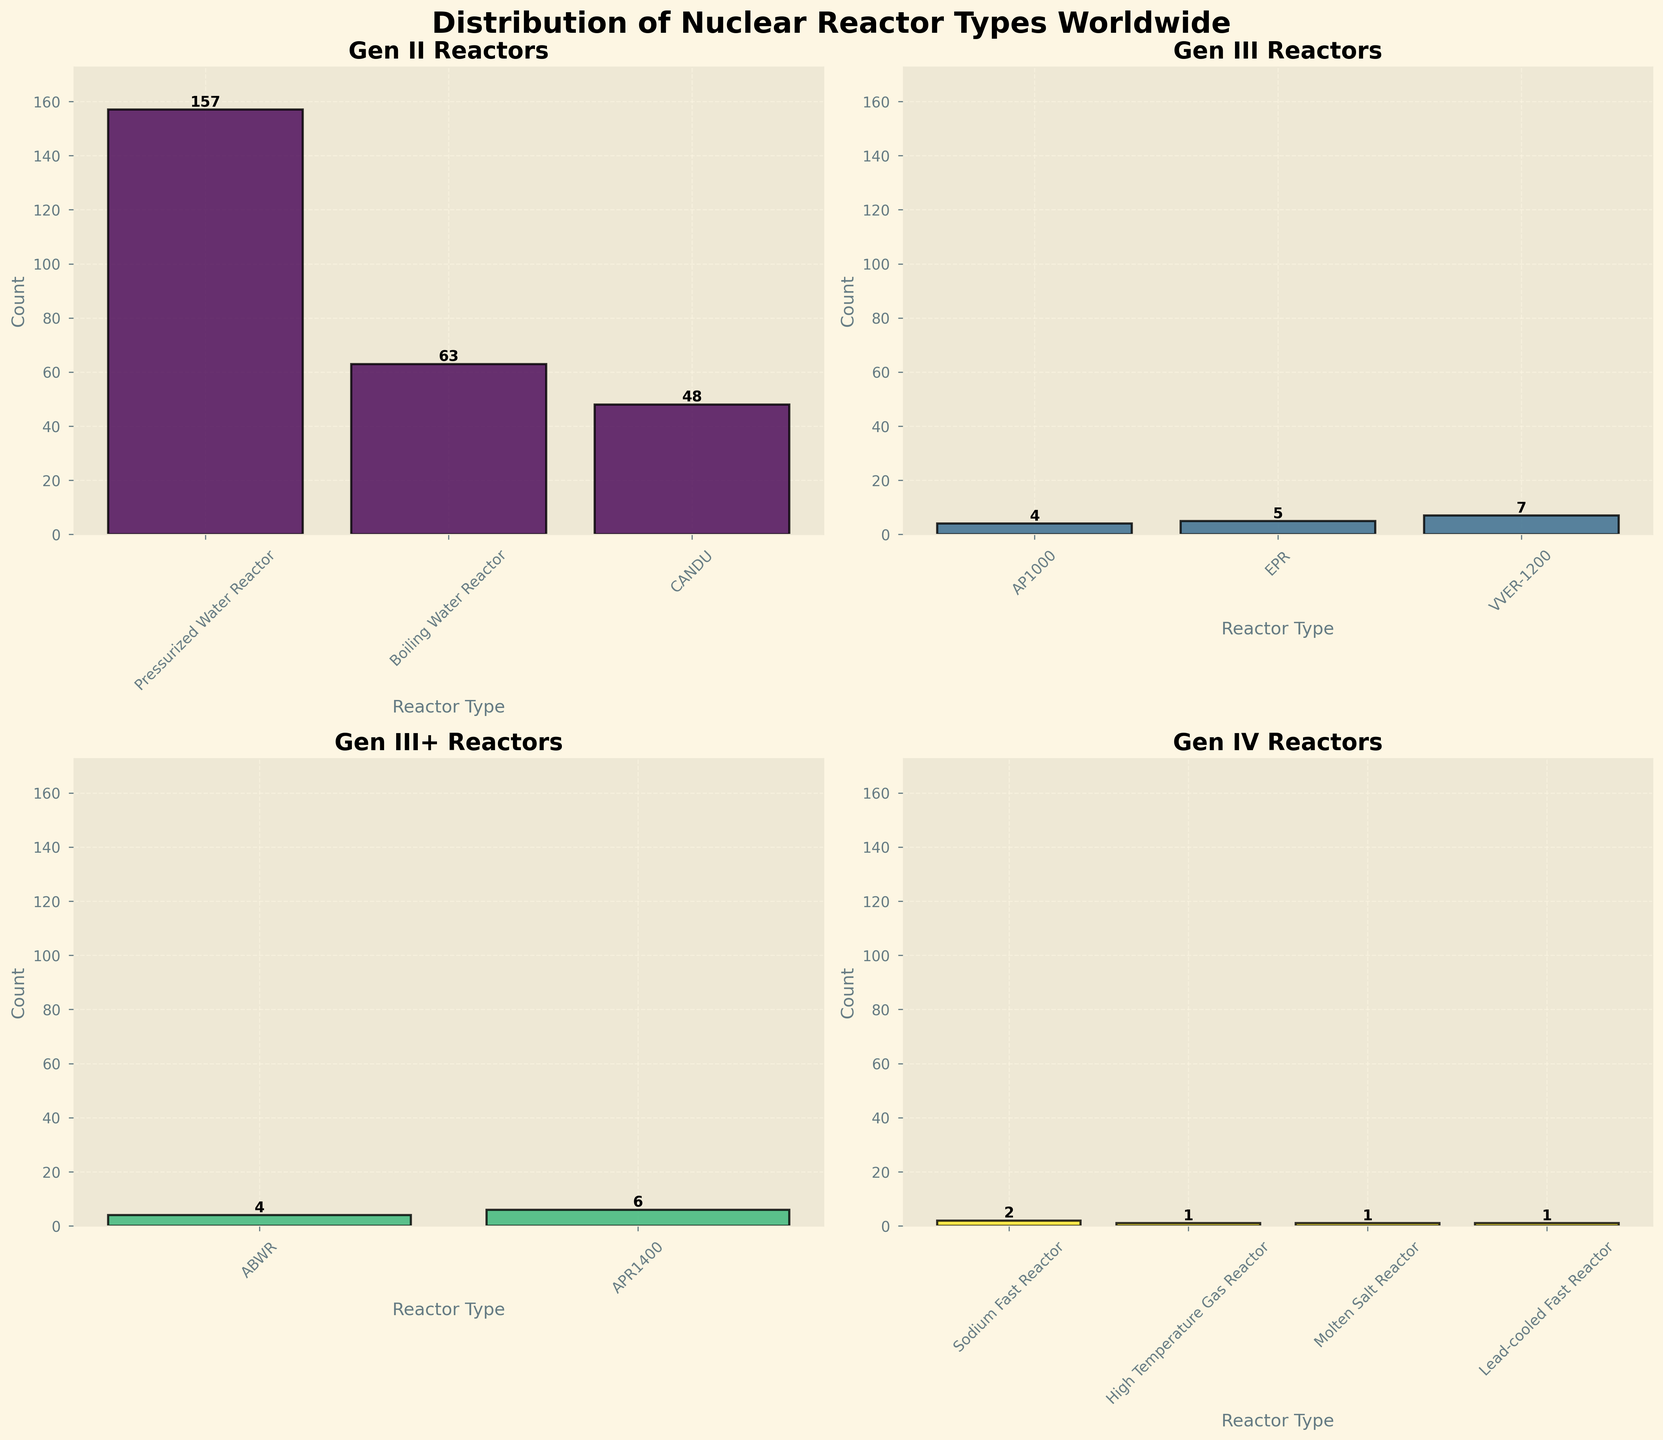What is the total number of Pressurized Water Reactors in the plot? To find the total number, look for the bar labeled "Pressurized Water Reactor" under the subplot titled "Gen II Reactors." The number on top of the bar shows that there are 157 Pressurized Water Reactors.
Answer: 157 Which generation has the highest count of reactors? By observing the height of the bars in all subplots, it is evident that "Gen II Reactors" have the highest count, particularly the Pressurized Water Reactor (157).
Answer: Gen II How many types of reactors are highlighted in the "Gen IV Reactors" subplot? Count the different bars in the "Gen IV Reactors" subplot; in total, there are four different reactor types shown.
Answer: 4 What is the combined capacity for the reactors in the "Gen III Reactors" category? Sum up the capacities from the data for AP1000 (1100 MWe), EPR (1600 MWe), and VVER-1200 (1200 MWe): 1100 + 1600 + 1200 = 3900 MWe.
Answer: 3900 MW Which type of reactor in the "Gen III+ Reactors" category has the smallest count and what is this count? In the "Gen III+ Reactors" subplot, compare the heights of the bars for ABWR and APR1400. The ABWR has a smaller count, and the number on top of the bar shows 4.
Answer: ABWR, 4 How does the count of CANDU reactors compare to that of Boiling Water Reactors in the "Gen II Reactors" category? In the "Gen II Reactors" subplot, observe the bars labeled "CANDU" and "Boiling Water Reactor" and note the numbers on top: 48 (CANDU) vs. 63 (Boiling Water Reactor). The Boiling Water Reactors are greater.
Answer: Boiling Water Reactors have more What is the approximate height difference between the tallest and shortest bars in the "Gen IV Reactors" category? The tallest bar represents Sodium Fast Reactor with a count of 2. The shortest bars represent High Temperature Gas Reactor, Molten Salt Reactor, and Lead-cooled Fast Reactor, each with a count of 1. The height difference is 2 - 1 = 1.
Answer: 1 What is the total number of reactor types depicted across all subplots? Count the total distinct reactor types: Pressurized Water Reactor, Boiling Water Reactor, CANDU, AP1000, EPR, VVER-1200, ABWR, APR1400, Sodium Fast Reactor, High Temperature Gas Reactor, Molten Salt Reactor, Lead-cooled Fast Reactor. This gives 12 reactor types in total.
Answer: 12 Which reactor type is only represented by a single unit in the plot? Observe which bars are labeled with the number 1 across all subplots, notably the High Temperature Gas Reactor, Molten Salt Reactor, and Lead-cooled Fast Reactor in the "Gen IV Reactors" subplot.
Answer: High Temperature Gas Reactor, Molten Salt Reactor, Lead-cooled Fast Reactor 